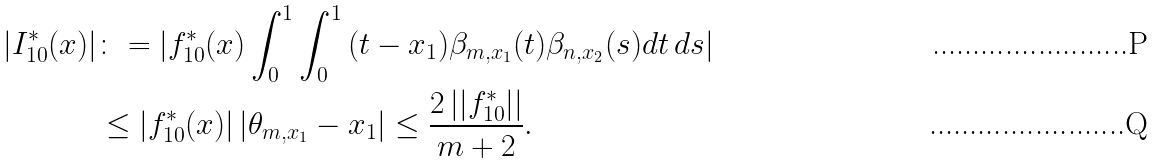Convert formula to latex. <formula><loc_0><loc_0><loc_500><loc_500>| I ^ { * } _ { 1 0 } ( x ) | & \colon = | f ^ { * } _ { 1 0 } ( x ) \int _ { 0 } ^ { 1 } \int _ { 0 } ^ { 1 } \, ( t - x _ { 1 } ) \beta _ { m , x _ { 1 } } ( t ) \beta _ { n , x _ { 2 } } ( s ) d t \, d s | \\ & \leq | f ^ { * } _ { 1 0 } ( x ) | \, | \theta _ { m , x _ { 1 } } - x _ { 1 } | \leq \frac { 2 \, | | f ^ { * } _ { 1 0 } | | } { m + 2 } .</formula> 